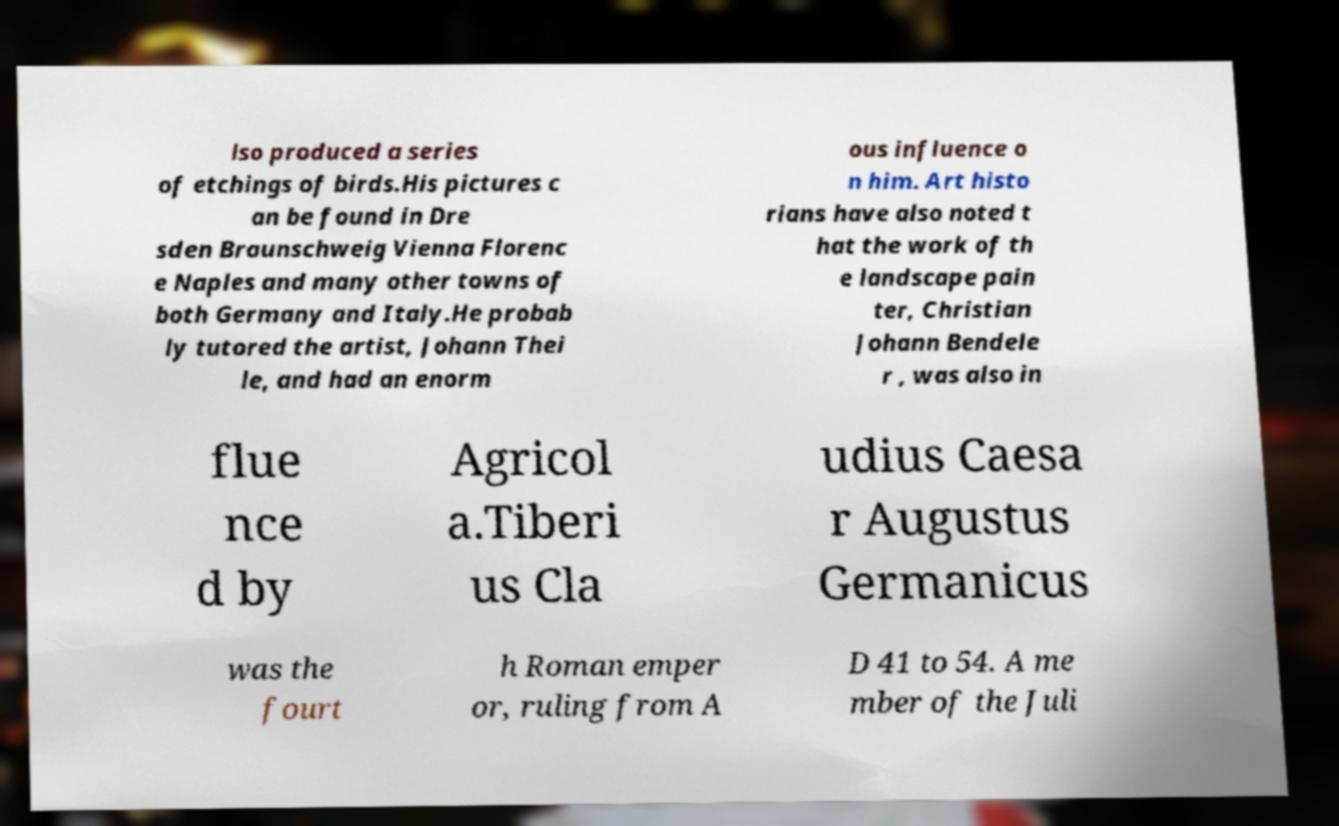For documentation purposes, I need the text within this image transcribed. Could you provide that? lso produced a series of etchings of birds.His pictures c an be found in Dre sden Braunschweig Vienna Florenc e Naples and many other towns of both Germany and Italy.He probab ly tutored the artist, Johann Thei le, and had an enorm ous influence o n him. Art histo rians have also noted t hat the work of th e landscape pain ter, Christian Johann Bendele r , was also in flue nce d by Agricol a.Tiberi us Cla udius Caesa r Augustus Germanicus was the fourt h Roman emper or, ruling from A D 41 to 54. A me mber of the Juli 